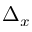<formula> <loc_0><loc_0><loc_500><loc_500>\Delta _ { x }</formula> 